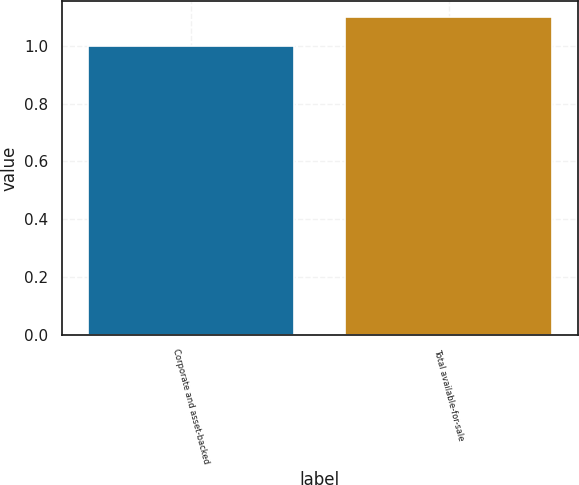<chart> <loc_0><loc_0><loc_500><loc_500><bar_chart><fcel>Corporate and asset-backed<fcel>Total available-for-sale<nl><fcel>1<fcel>1.1<nl></chart> 